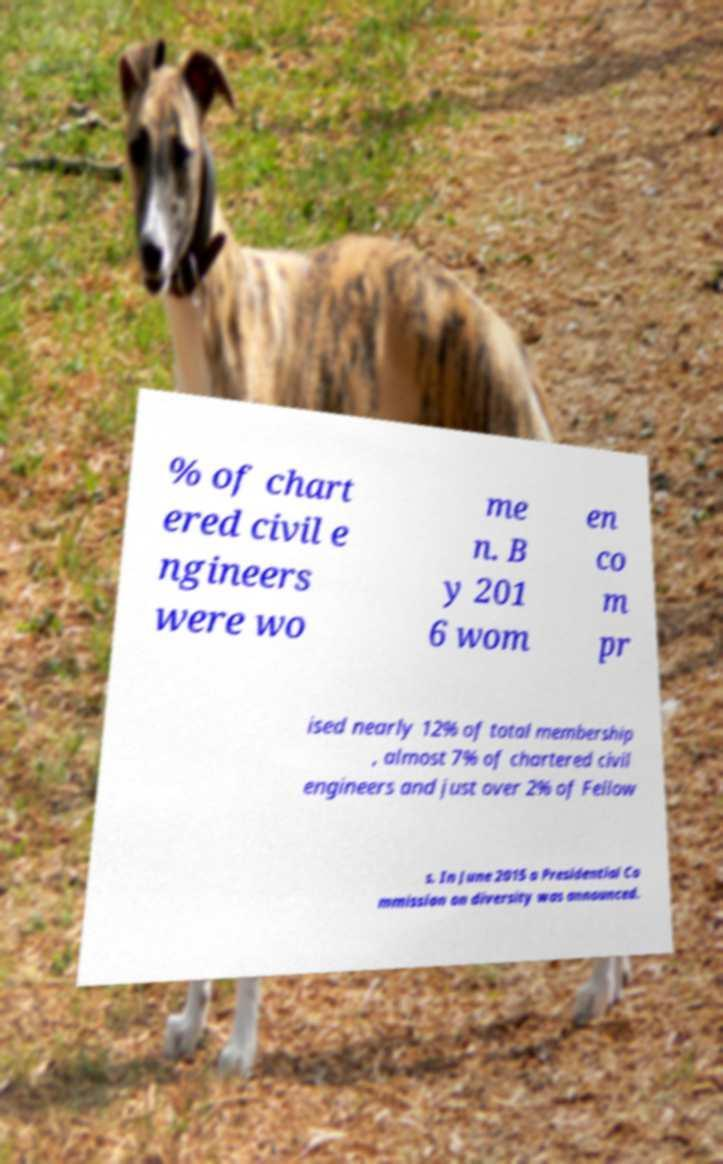Can you accurately transcribe the text from the provided image for me? % of chart ered civil e ngineers were wo me n. B y 201 6 wom en co m pr ised nearly 12% of total membership , almost 7% of chartered civil engineers and just over 2% of Fellow s. In June 2015 a Presidential Co mmission on diversity was announced. 